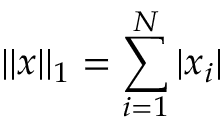Convert formula to latex. <formula><loc_0><loc_0><loc_500><loc_500>| | x | | _ { 1 } = \sum _ { i = 1 } ^ { N } | x _ { i } |</formula> 